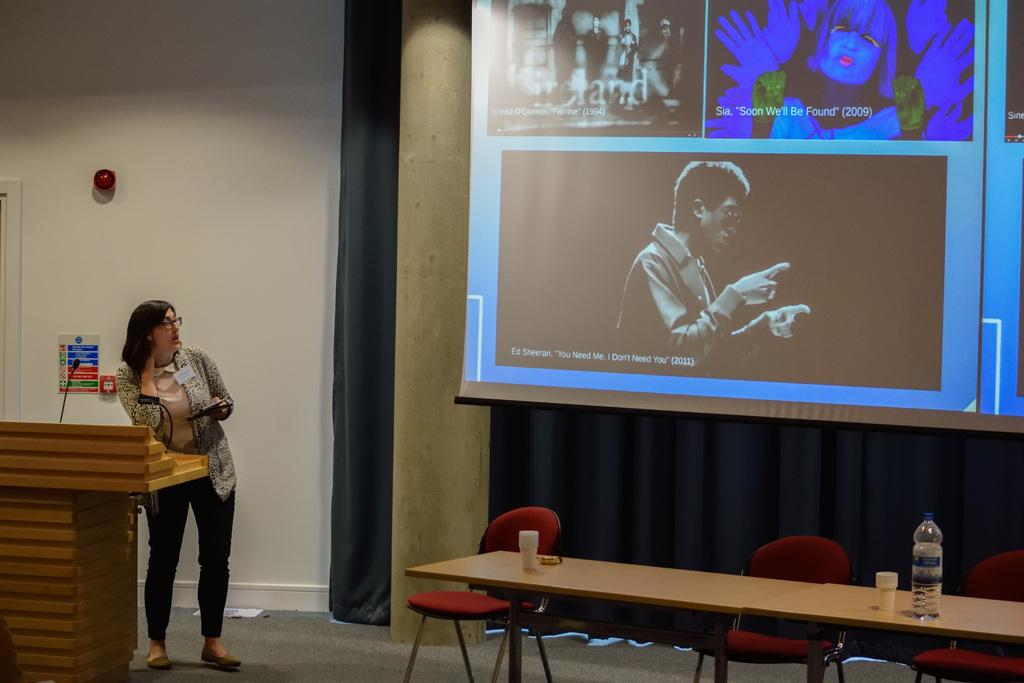What is the woman doing on the left side of the image? The woman is standing on the left side of the image and holding a tab. What is in front of the woman? There is a wood stand in front of the woman. What can be seen in the background of the image? In the background of the image, there is a screen, a pillar, a curtain, a table, a chair, and water bottles. What type of dinner is being served in the image? There is no dinner being served in the image; it only shows a woman standing with a wood stand in front of her and various objects in the background. 